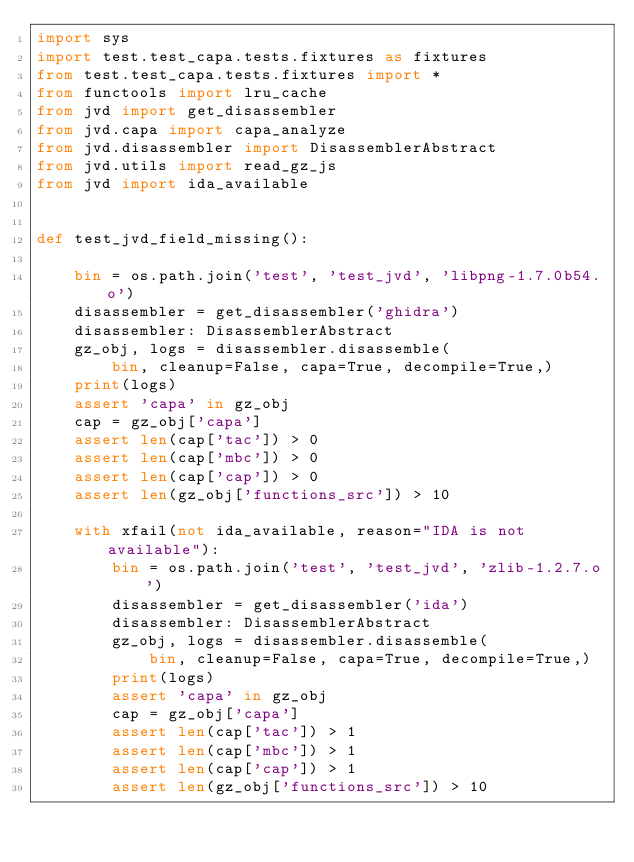Convert code to text. <code><loc_0><loc_0><loc_500><loc_500><_Python_>import sys
import test.test_capa.tests.fixtures as fixtures
from test.test_capa.tests.fixtures import *
from functools import lru_cache
from jvd import get_disassembler
from jvd.capa import capa_analyze
from jvd.disassembler import DisassemblerAbstract
from jvd.utils import read_gz_js
from jvd import ida_available


def test_jvd_field_missing():

    bin = os.path.join('test', 'test_jvd', 'libpng-1.7.0b54.o')
    disassembler = get_disassembler('ghidra')
    disassembler: DisassemblerAbstract
    gz_obj, logs = disassembler.disassemble(
        bin, cleanup=False, capa=True, decompile=True,)
    print(logs)
    assert 'capa' in gz_obj
    cap = gz_obj['capa']
    assert len(cap['tac']) > 0
    assert len(cap['mbc']) > 0
    assert len(cap['cap']) > 0
    assert len(gz_obj['functions_src']) > 10

    with xfail(not ida_available, reason="IDA is not available"):
        bin = os.path.join('test', 'test_jvd', 'zlib-1.2.7.o')
        disassembler = get_disassembler('ida')
        disassembler: DisassemblerAbstract
        gz_obj, logs = disassembler.disassemble(
            bin, cleanup=False, capa=True, decompile=True,)
        print(logs)
        assert 'capa' in gz_obj
        cap = gz_obj['capa']
        assert len(cap['tac']) > 1
        assert len(cap['mbc']) > 1
        assert len(cap['cap']) > 1
        assert len(gz_obj['functions_src']) > 10
</code> 